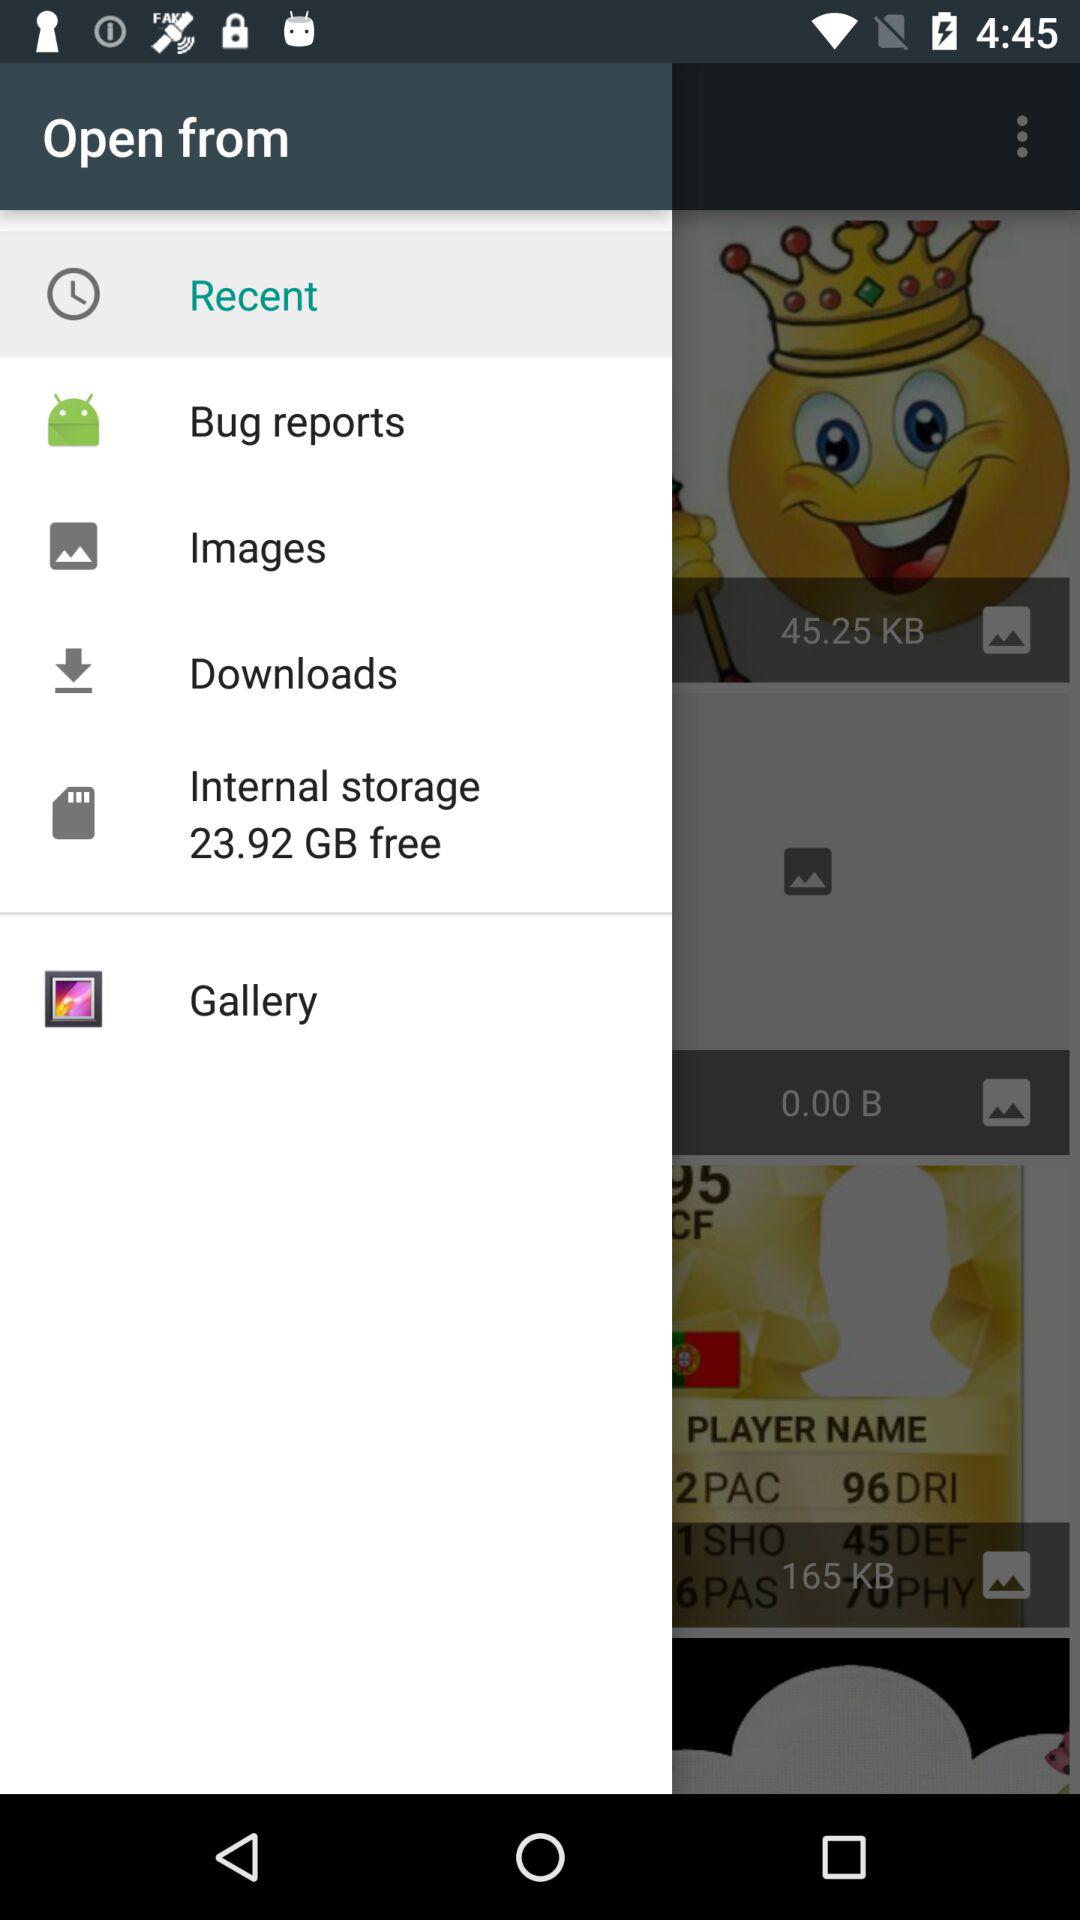How much internal storage is free? There is 23.92 GB of free internal storage. 